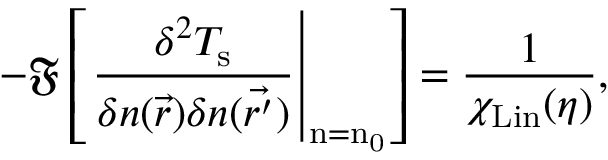<formula> <loc_0><loc_0><loc_500><loc_500>- \mathfrak { F } \left [ \frac { \delta ^ { 2 } T _ { s } } { \delta n ( \vec { r } ) \delta n ( \vec { r ^ { \prime } } ) } \right | _ { n = n _ { 0 } } \right ] = \frac { 1 } { \chi _ { L i n } ( \eta ) } ,</formula> 